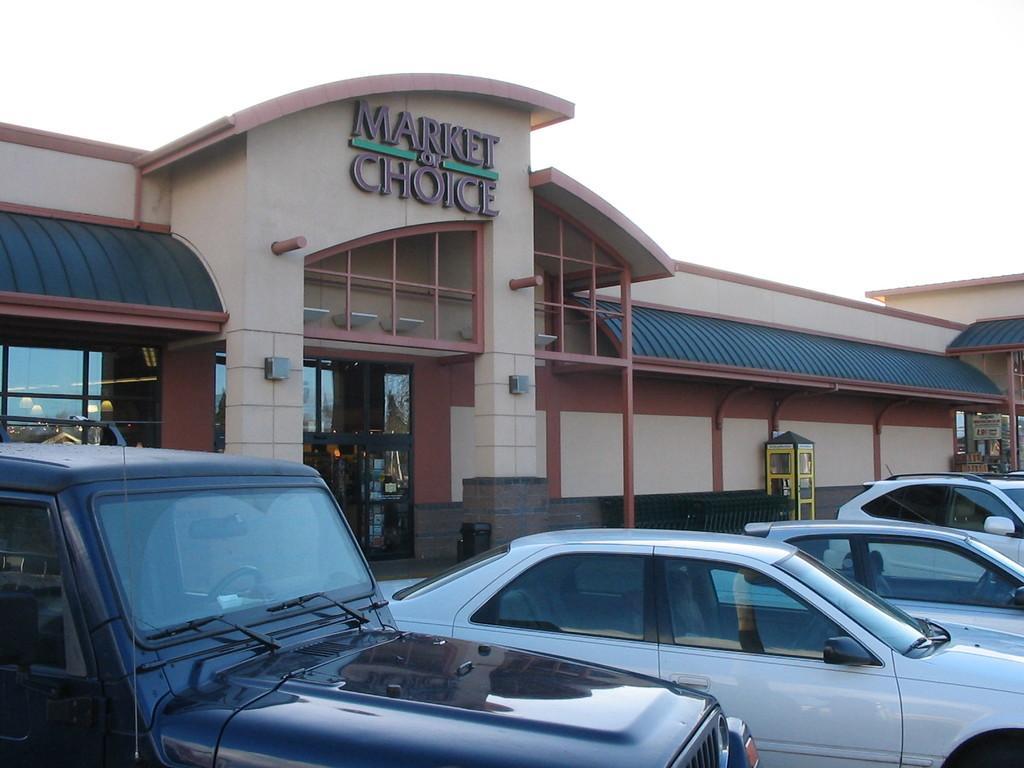Please provide a concise description of this image. In the center of the image we can see cars on the road. In the background we can see buildings, telephone booth, windows, door, pillars and sky. 